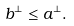<formula> <loc_0><loc_0><loc_500><loc_500>b ^ { \bot } \leq a ^ { \bot } .</formula> 